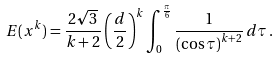Convert formula to latex. <formula><loc_0><loc_0><loc_500><loc_500>E ( x ^ { k } ) = \frac { 2 \sqrt { 3 } } { k + 2 } \left ( \frac { d } { 2 } \right ) ^ { k } \int _ { 0 } ^ { \frac { \pi } { 6 } } \frac { 1 } { \left ( \cos \tau \right ) ^ { k + 2 } } \, d \tau \, . \,</formula> 